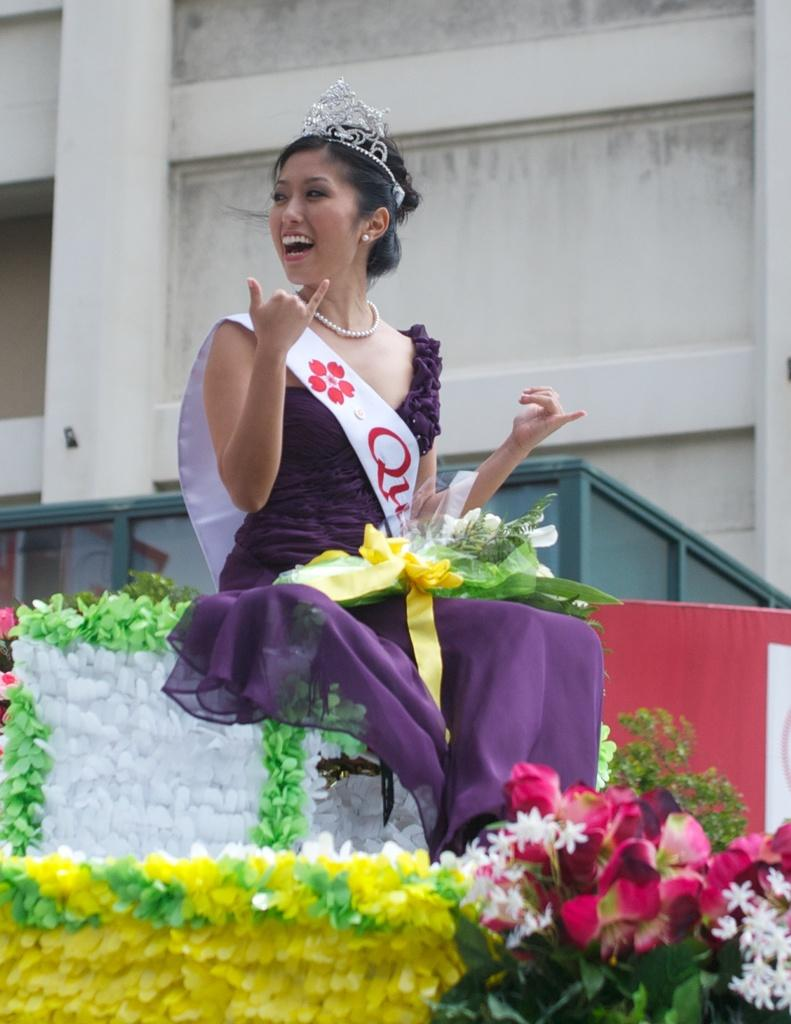What can be found at the bottom right corner of the image? There are flowers in the right-hand side bottom of the image. What is the main subject in the middle of the image? A woman is sitting in the middle of the image. What is the woman wearing? The woman is wearing a dress and a crown. What type of structure can be seen at the top of the image? There is a building visible at the top of the image. What type of berry is being used as a health supplement in the image? There is no berry present in the image, and no health supplements are mentioned. How does the woman react to the shocking news in the image? There is no indication of any shocking news or reaction in the image. 